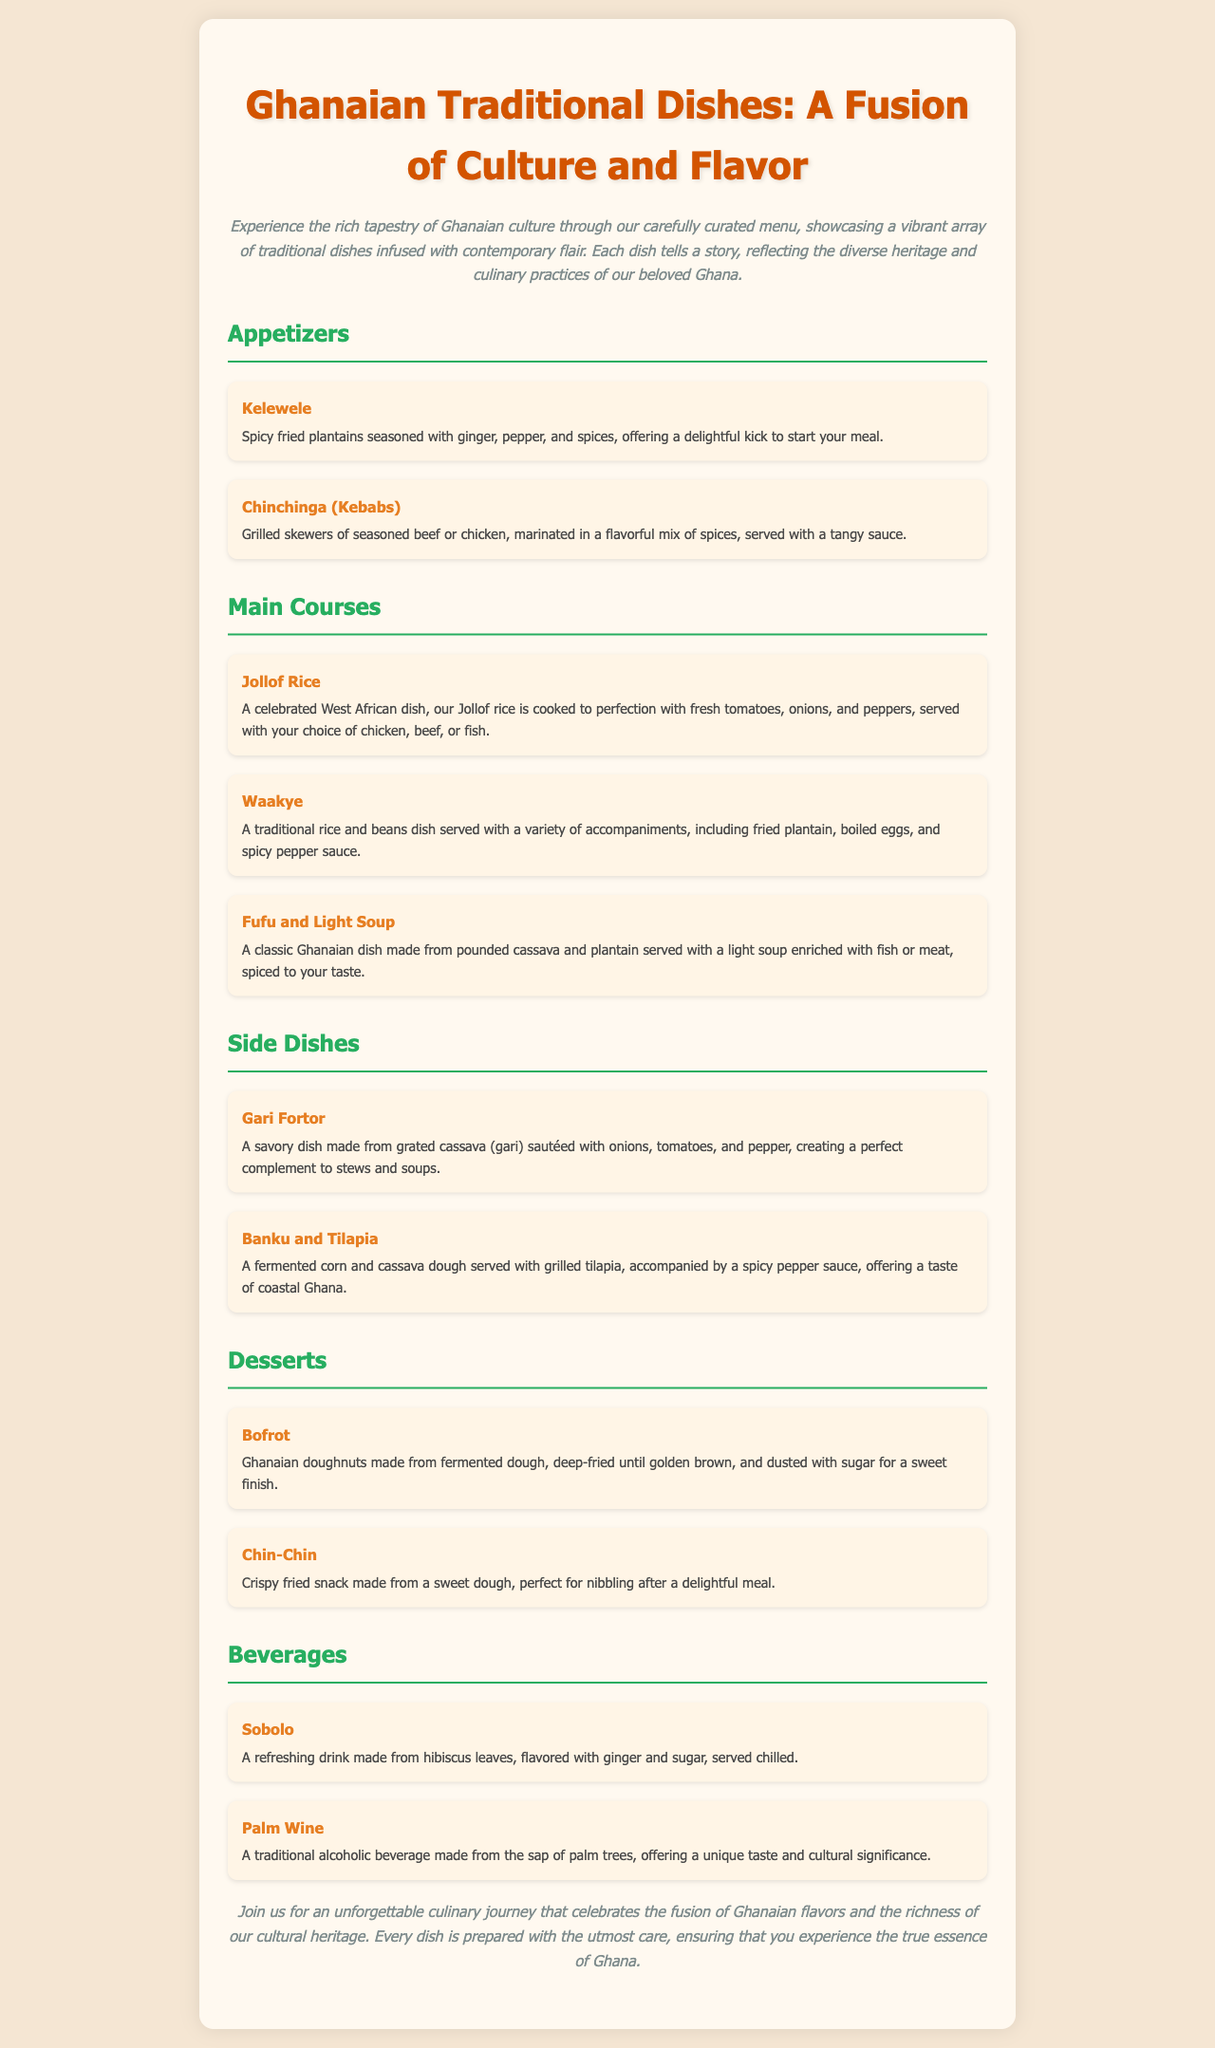what is the title of the document? The title of the document is prominently displayed at the top of the page.
Answer: Ghanaian Traditional Dishes: A Fusion of Culture and Flavor how many appetizers are listed? The document lists a section for appetizers and counts the items in that section.
Answer: 2 what is Kelewele? Kelewele is described as a spicy fried plantain dish in the appetizers section.
Answer: Spicy fried plantains what dish is served with grilled tilapia? The document provides a specific pairing for grilled tilapia in the side dishes section.
Answer: Banku and Tilapia what is the main ingredient in Fufu? The description of Fufu highlights the key ingredients used to prepare it.
Answer: Pounded cassava and plantain which beverage is made from hibiscus leaves? The beverages section specifically mentions a drink made from hibiscus leaves.
Answer: Sobolo how many main courses are included? By counting the items listed in the main courses section of the document.
Answer: 3 what type of dough is used to make Bofrot? The description of Bofrot indicates the composition of the dough used.
Answer: Fermented dough what unique feature does Chin-Chin have? The description of Chin-Chin mentions a particular characteristic that sets it apart.
Answer: Crispy fried snack 